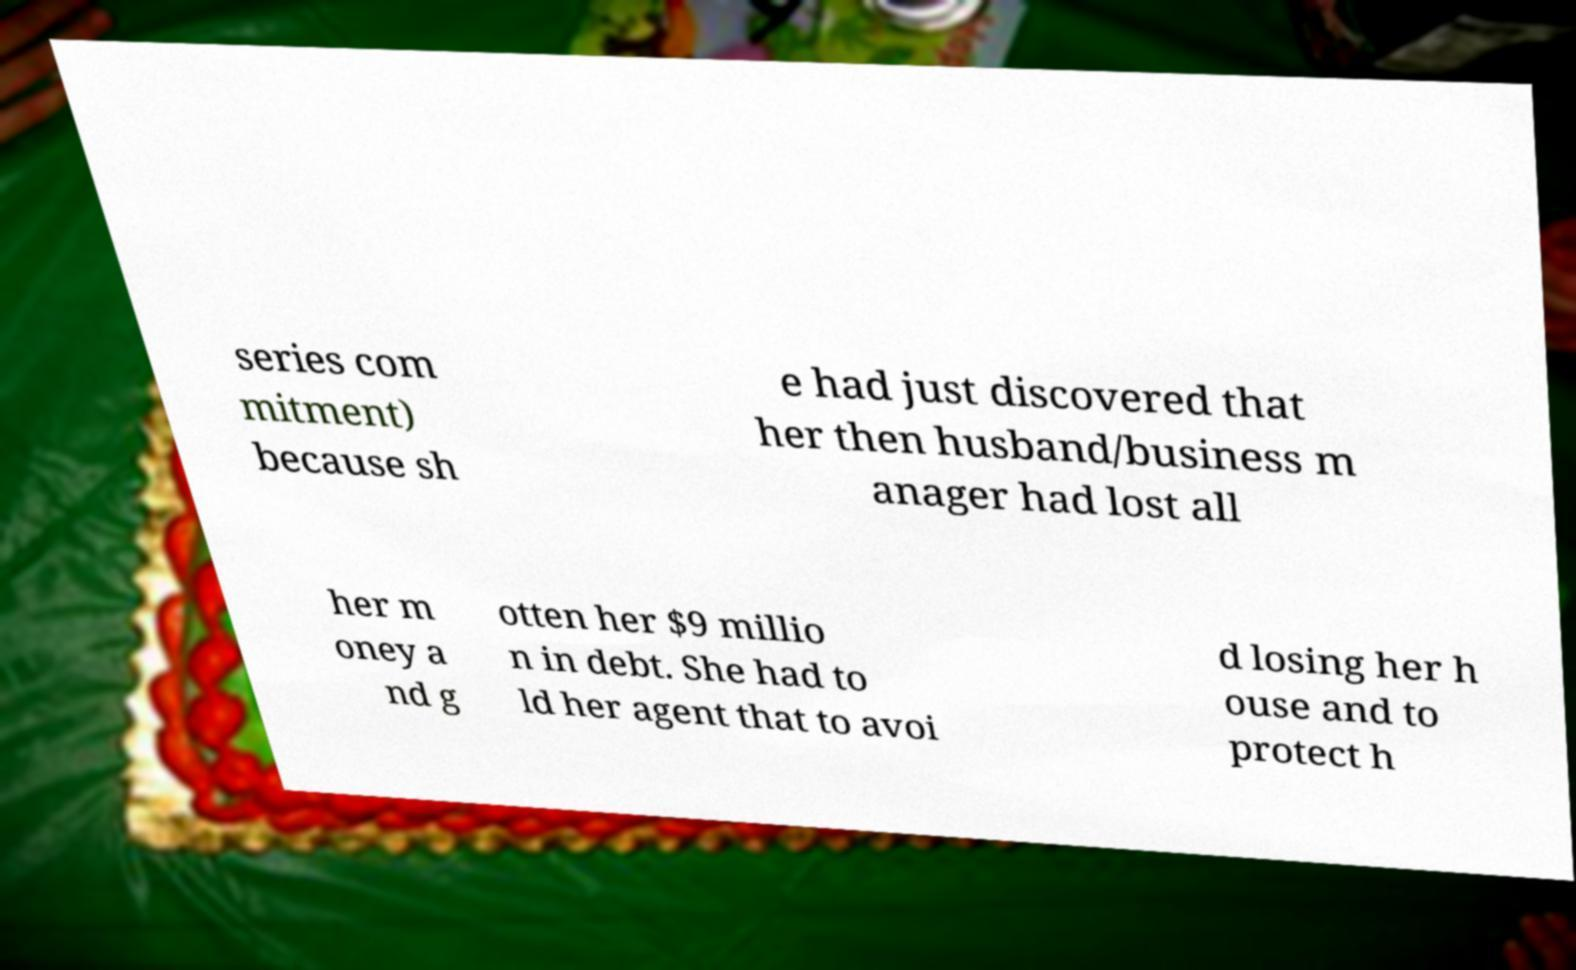Could you assist in decoding the text presented in this image and type it out clearly? series com mitment) because sh e had just discovered that her then husband/business m anager had lost all her m oney a nd g otten her $9 millio n in debt. She had to ld her agent that to avoi d losing her h ouse and to protect h 